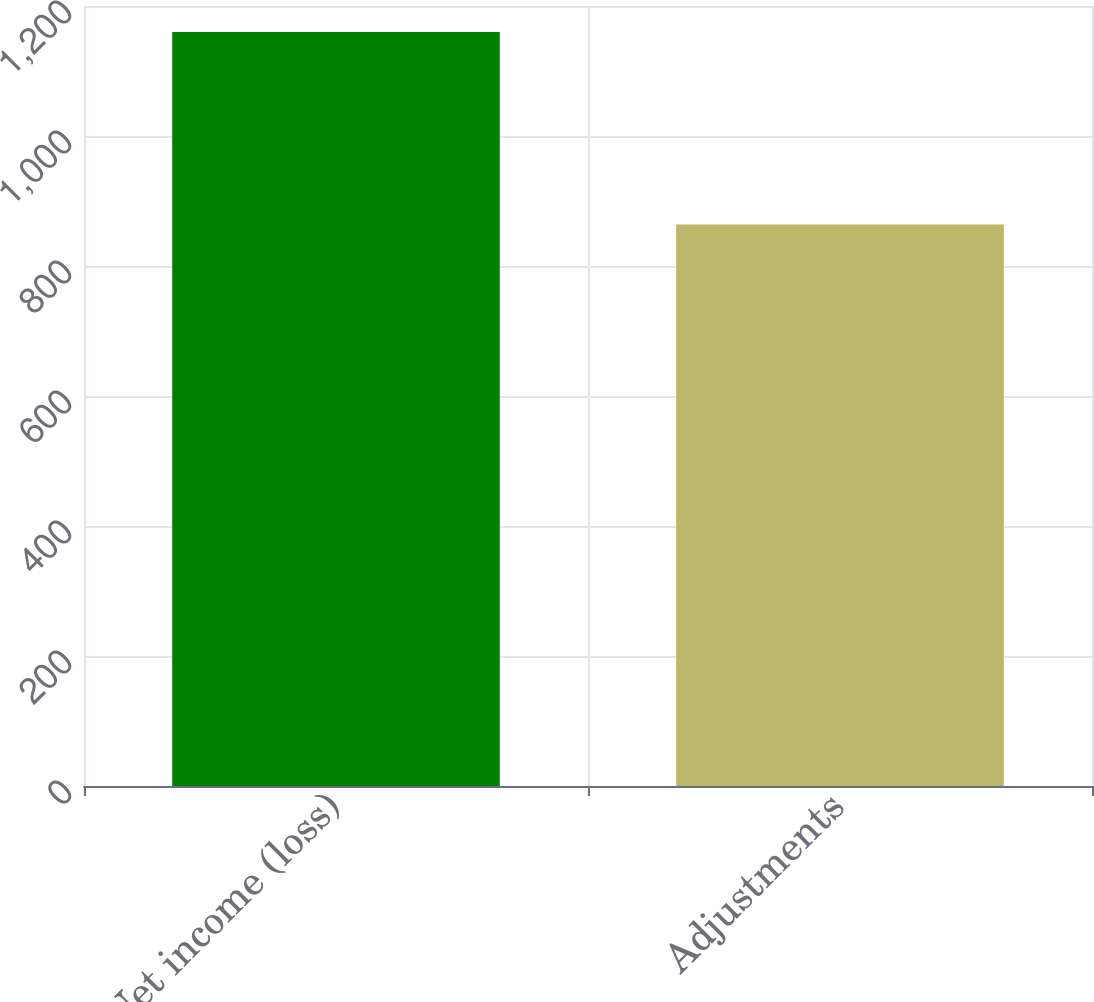<chart> <loc_0><loc_0><loc_500><loc_500><bar_chart><fcel>Net income (loss)<fcel>Adjustments<nl><fcel>1160<fcel>864<nl></chart> 